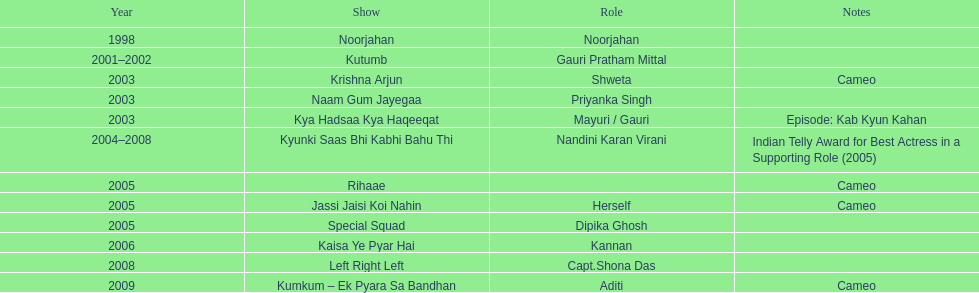Other than rihaae, in what alternate show did gauri tejwani have a guest appearance in 2005? Jassi Jaisi Koi Nahin. 